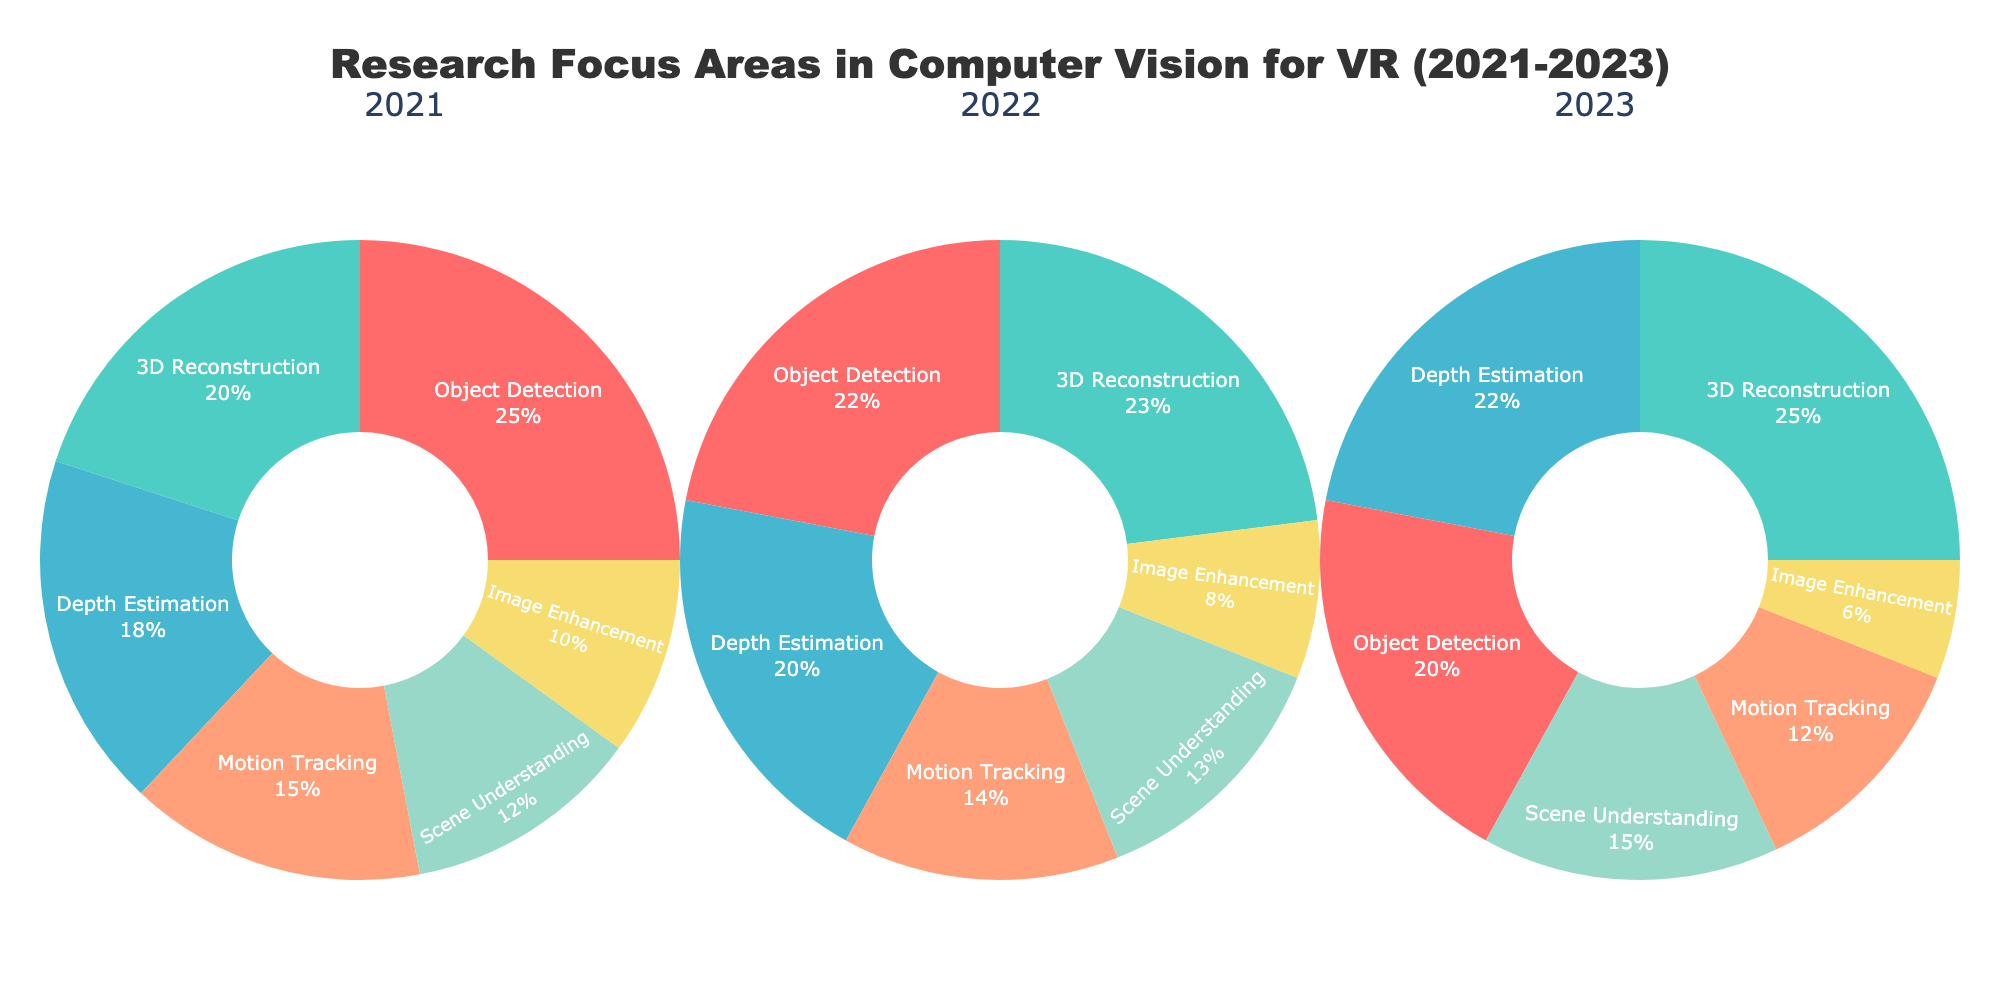What is the title of the figure? The title is located at the top center of the figure. It reads: "Research Focus Areas in Computer Vision for VR (2021-2023)".
Answer: Research Focus Areas in Computer Vision for VR (2021-2023) Which research focus area had the highest percentage in 2023? We need to look at the pie chart segment for 2023 and identify the largest segment. "3D Reconstruction" takes up the largest portion in 2023.
Answer: 3D Reconstruction By how many percentage points did the focus on "Object Detection" decrease from 2021 to 2023? Check the percentage for "Object Detection" in both 2021 and 2023. In 2021, it’s 25% and in 2023, it’s 20%. Subtracting these gives 25% - 20% = 5%.
Answer: 5 What is the smallest research focus area in 2022? By examining the 2022 pie chart, we determine the smallest segment. "Image Enhancement" appears to be the smallest.
Answer: Image Enhancement How did the focus on "Depth Estimation" change over the years? Look at the percentages for "Depth Estimation" in 2021, 2022, and 2023. They are 18%, 20%, and 22% respectively.
Answer: Increased Compare the percentage of "3D Reconstruction" in 2021 and 2022. Which year had a higher focus? For 3D Reconstruction: 2021 has 20% and 2022 has 23%. Therefore, 2022 had a higher focus.
Answer: 2022 Calculate the total percentage for "Motion Tracking" over the three years. Sum the percentages for "Motion Tracking" from 2021, 2022, and 2023: 15% + 14% + 12% = 41%.
Answer: 41 Which focus area consistently increased its percentage share each year? By checking each area across the years, "Depth Estimation" shows a continuous increase (18% in 2021, 20% in 2022, 22% in 2023).
Answer: Depth Estimation What percentage of the total research focus did "Scene Understanding" account for in 2021 and 2023 combined? Add the percentages from both years: 12% (2021) + 15% (2023) = 27%.
Answer: 27 Which research area had exactly the same percentage in both 2021 and 2022? Compare the values of each research area for these two years. None of the values are exactly the same for both years.
Answer: None 